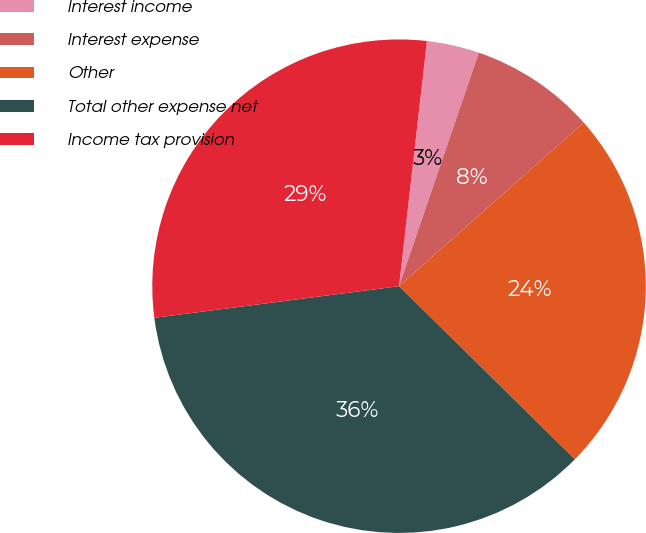Convert chart. <chart><loc_0><loc_0><loc_500><loc_500><pie_chart><fcel>Interest income<fcel>Interest expense<fcel>Other<fcel>Total other expense net<fcel>Income tax provision<nl><fcel>3.44%<fcel>8.22%<fcel>23.92%<fcel>35.58%<fcel>28.85%<nl></chart> 